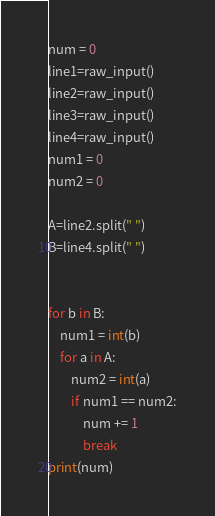<code> <loc_0><loc_0><loc_500><loc_500><_Python_>num = 0
line1=raw_input()
line2=raw_input()
line3=raw_input()
line4=raw_input()
num1 = 0
num2 = 0

A=line2.split(" ")
B=line4.split(" ")


for b in B:
    num1 = int(b)
    for a in A:
        num2 = int(a)
        if num1 == num2:
            num += 1 
            break
print(num)
</code> 